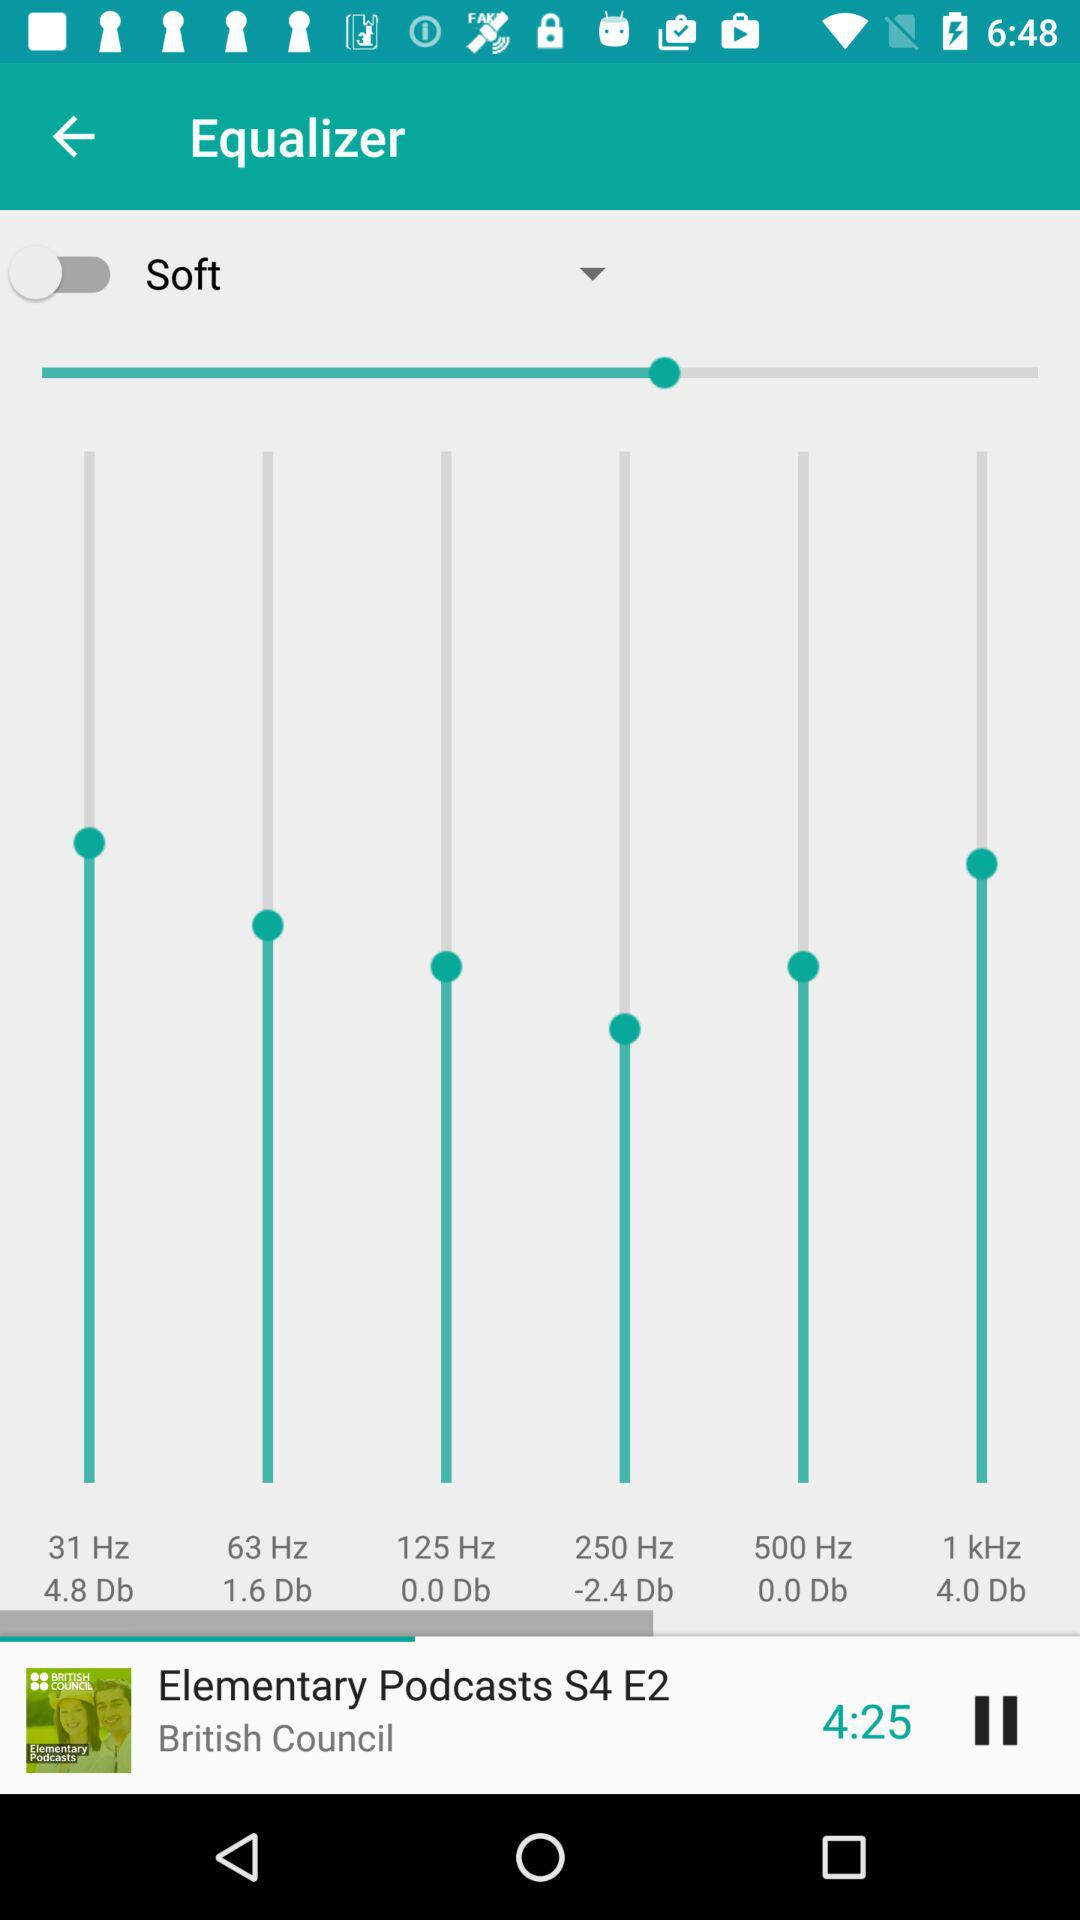Which season of "Elementary Podcasts" is playing? The season is "S4". 